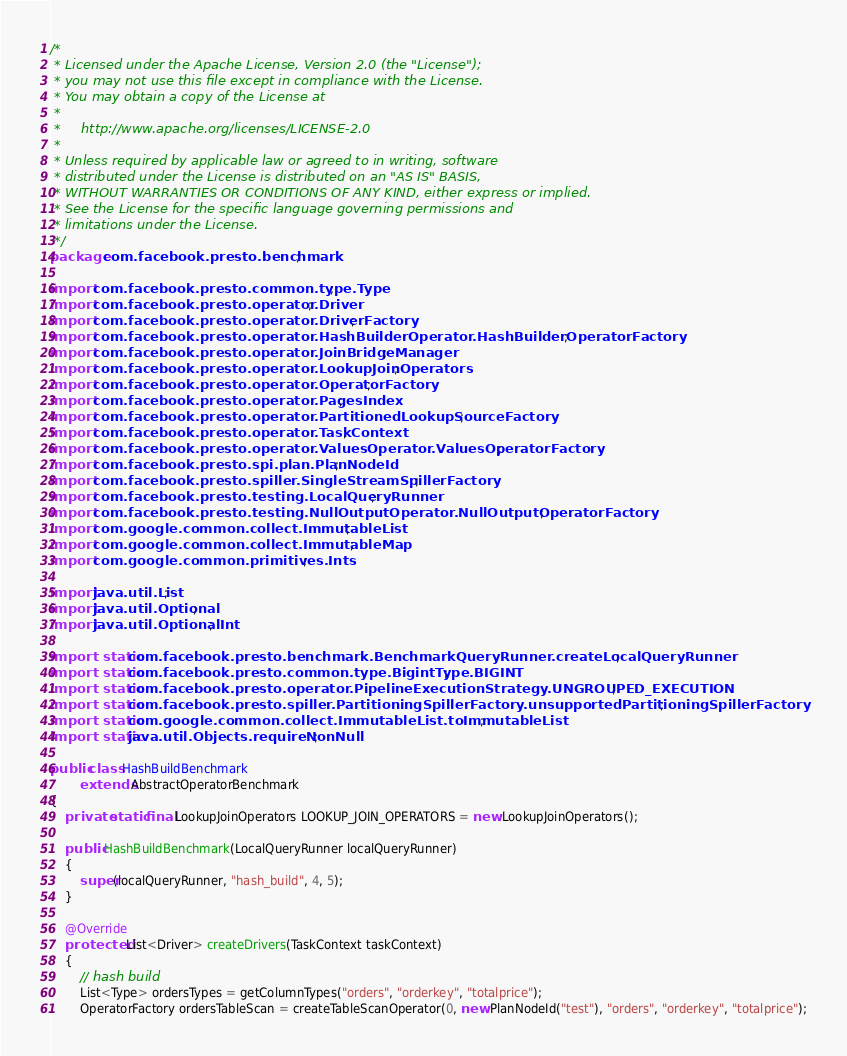Convert code to text. <code><loc_0><loc_0><loc_500><loc_500><_Java_>/*
 * Licensed under the Apache License, Version 2.0 (the "License");
 * you may not use this file except in compliance with the License.
 * You may obtain a copy of the License at
 *
 *     http://www.apache.org/licenses/LICENSE-2.0
 *
 * Unless required by applicable law or agreed to in writing, software
 * distributed under the License is distributed on an "AS IS" BASIS,
 * WITHOUT WARRANTIES OR CONDITIONS OF ANY KIND, either express or implied.
 * See the License for the specific language governing permissions and
 * limitations under the License.
 */
package com.facebook.presto.benchmark;

import com.facebook.presto.common.type.Type;
import com.facebook.presto.operator.Driver;
import com.facebook.presto.operator.DriverFactory;
import com.facebook.presto.operator.HashBuilderOperator.HashBuilderOperatorFactory;
import com.facebook.presto.operator.JoinBridgeManager;
import com.facebook.presto.operator.LookupJoinOperators;
import com.facebook.presto.operator.OperatorFactory;
import com.facebook.presto.operator.PagesIndex;
import com.facebook.presto.operator.PartitionedLookupSourceFactory;
import com.facebook.presto.operator.TaskContext;
import com.facebook.presto.operator.ValuesOperator.ValuesOperatorFactory;
import com.facebook.presto.spi.plan.PlanNodeId;
import com.facebook.presto.spiller.SingleStreamSpillerFactory;
import com.facebook.presto.testing.LocalQueryRunner;
import com.facebook.presto.testing.NullOutputOperator.NullOutputOperatorFactory;
import com.google.common.collect.ImmutableList;
import com.google.common.collect.ImmutableMap;
import com.google.common.primitives.Ints;

import java.util.List;
import java.util.Optional;
import java.util.OptionalInt;

import static com.facebook.presto.benchmark.BenchmarkQueryRunner.createLocalQueryRunner;
import static com.facebook.presto.common.type.BigintType.BIGINT;
import static com.facebook.presto.operator.PipelineExecutionStrategy.UNGROUPED_EXECUTION;
import static com.facebook.presto.spiller.PartitioningSpillerFactory.unsupportedPartitioningSpillerFactory;
import static com.google.common.collect.ImmutableList.toImmutableList;
import static java.util.Objects.requireNonNull;

public class HashBuildBenchmark
        extends AbstractOperatorBenchmark
{
    private static final LookupJoinOperators LOOKUP_JOIN_OPERATORS = new LookupJoinOperators();

    public HashBuildBenchmark(LocalQueryRunner localQueryRunner)
    {
        super(localQueryRunner, "hash_build", 4, 5);
    }

    @Override
    protected List<Driver> createDrivers(TaskContext taskContext)
    {
        // hash build
        List<Type> ordersTypes = getColumnTypes("orders", "orderkey", "totalprice");
        OperatorFactory ordersTableScan = createTableScanOperator(0, new PlanNodeId("test"), "orders", "orderkey", "totalprice");</code> 